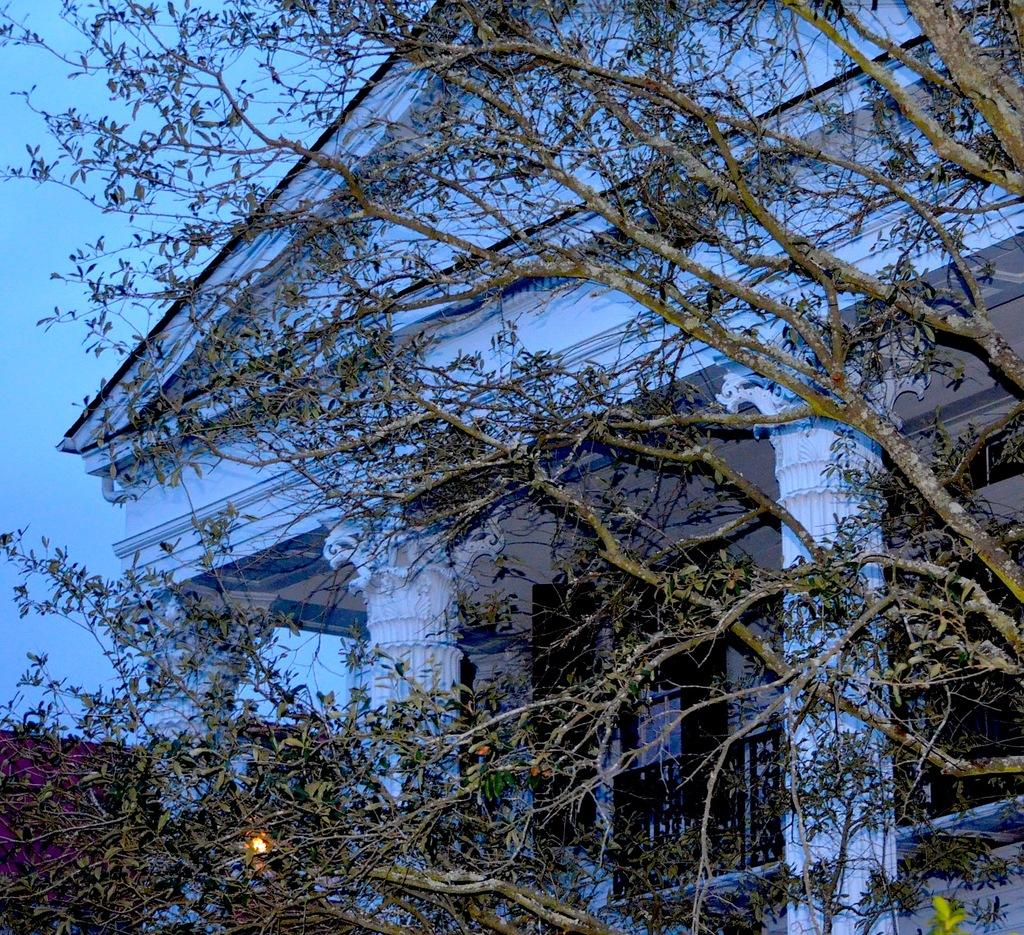What can be seen in the foreground of the image? There are tree branches in the front of the image. What type of structure is visible in the image? There is a white color building in the image. What architectural feature is present on the building? The building has big pillars. How many beds can be seen in the image? There are no beds present in the image; it features a white building with big pillars and tree branches in the foreground. What type of record is being played in the image? There is no record or music player present in the image. 